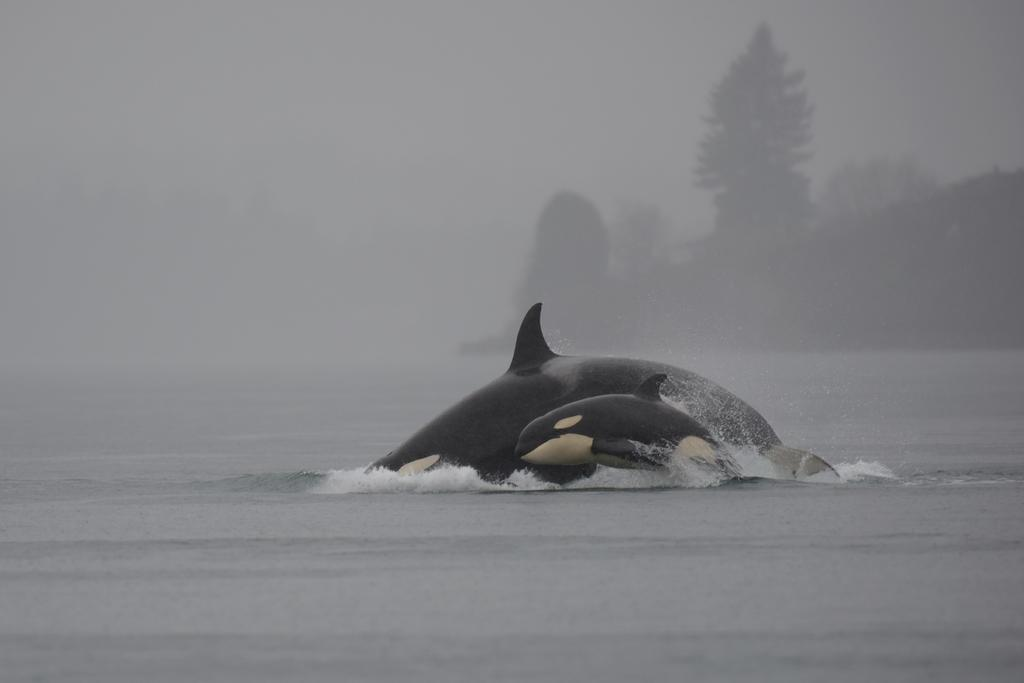What animals can be seen in the water in the image? There are two whales in the water in the image. What is the condition of the background in the image? The background of the image contains fog. What can be seen through the fog in the background? Trees are visible through the fog in the background. What type of clam is sitting on the table in the image? There is no table or clam present in the image; it features two whales in the water with a foggy background. How many bags of popcorn are visible on the floor in the image? There are no bags of popcorn present in the image. 